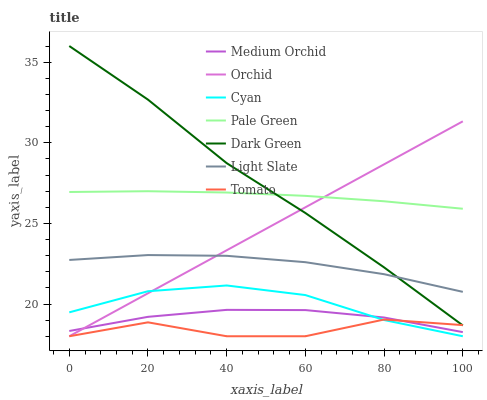Does Tomato have the minimum area under the curve?
Answer yes or no. Yes. Does Dark Green have the maximum area under the curve?
Answer yes or no. Yes. Does Light Slate have the minimum area under the curve?
Answer yes or no. No. Does Light Slate have the maximum area under the curve?
Answer yes or no. No. Is Orchid the smoothest?
Answer yes or no. Yes. Is Tomato the roughest?
Answer yes or no. Yes. Is Light Slate the smoothest?
Answer yes or no. No. Is Light Slate the roughest?
Answer yes or no. No. Does Light Slate have the lowest value?
Answer yes or no. No. Does Light Slate have the highest value?
Answer yes or no. No. Is Medium Orchid less than Light Slate?
Answer yes or no. Yes. Is Pale Green greater than Medium Orchid?
Answer yes or no. Yes. Does Medium Orchid intersect Light Slate?
Answer yes or no. No. 